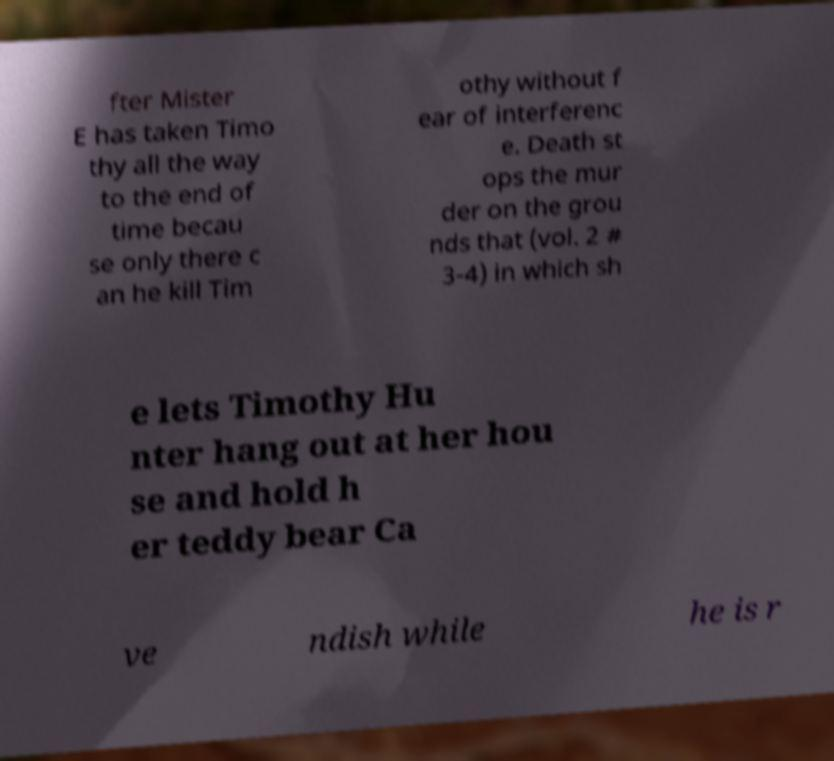Please identify and transcribe the text found in this image. fter Mister E has taken Timo thy all the way to the end of time becau se only there c an he kill Tim othy without f ear of interferenc e. Death st ops the mur der on the grou nds that (vol. 2 # 3-4) in which sh e lets Timothy Hu nter hang out at her hou se and hold h er teddy bear Ca ve ndish while he is r 